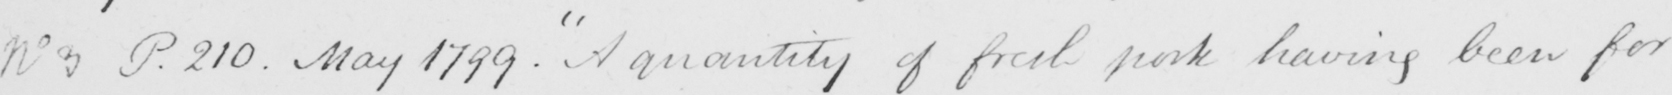What is written in this line of handwriting? No 3 P . 210 . May 1799 . A quantity of fresh pork having been for 